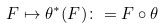<formula> <loc_0><loc_0><loc_500><loc_500>F \mapsto \theta ^ { * } ( F ) \colon = F \circ \theta</formula> 